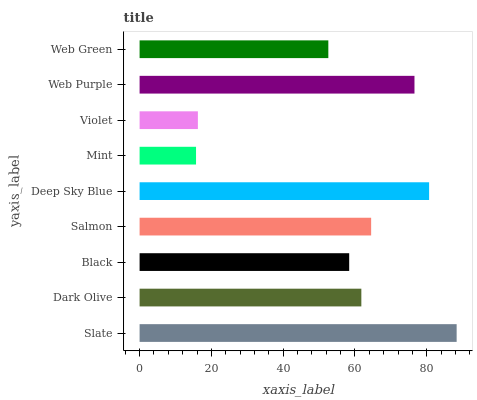Is Mint the minimum?
Answer yes or no. Yes. Is Slate the maximum?
Answer yes or no. Yes. Is Dark Olive the minimum?
Answer yes or no. No. Is Dark Olive the maximum?
Answer yes or no. No. Is Slate greater than Dark Olive?
Answer yes or no. Yes. Is Dark Olive less than Slate?
Answer yes or no. Yes. Is Dark Olive greater than Slate?
Answer yes or no. No. Is Slate less than Dark Olive?
Answer yes or no. No. Is Dark Olive the high median?
Answer yes or no. Yes. Is Dark Olive the low median?
Answer yes or no. Yes. Is Salmon the high median?
Answer yes or no. No. Is Salmon the low median?
Answer yes or no. No. 